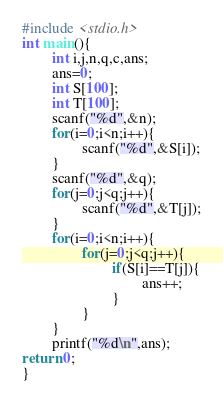Convert code to text. <code><loc_0><loc_0><loc_500><loc_500><_C_>#include <stdio.h>
int main(){
        int i,j,n,q,c,ans;
        ans=0;
        int S[100];
        int T[100];
        scanf("%d",&n);
        for(i=0;i<n;i++){
                scanf("%d",&S[i]);
        }
        scanf("%d",&q);
        for(j=0;j<q;j++){
                scanf("%d",&T[j]);
        }
        for(i=0;i<n;i++){
                for(j=0;j<q;j++){
                        if(S[i]==T[j]){
                                ans++;
                        }
                }
        }
        printf("%d\n",ans);
return 0;
}</code> 